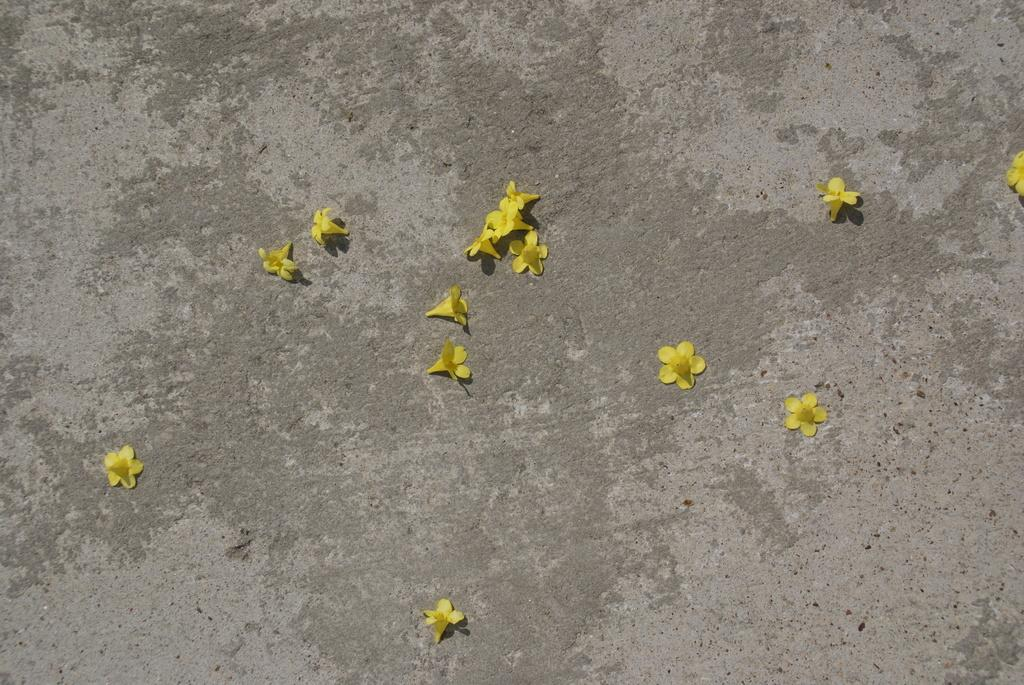What type of plants can be seen in the image? There are flowers in the image. What color are the flowers? The flowers are yellow in color. Where are the flowers located in the image? The flowers are on the road. What type of hook can be seen attached to the flowers in the image? There is no hook present in the image; it features only flowers on the road. What type of button is visible on the flowers in the image? There is no button present in the image; it features only flowers on the road. 